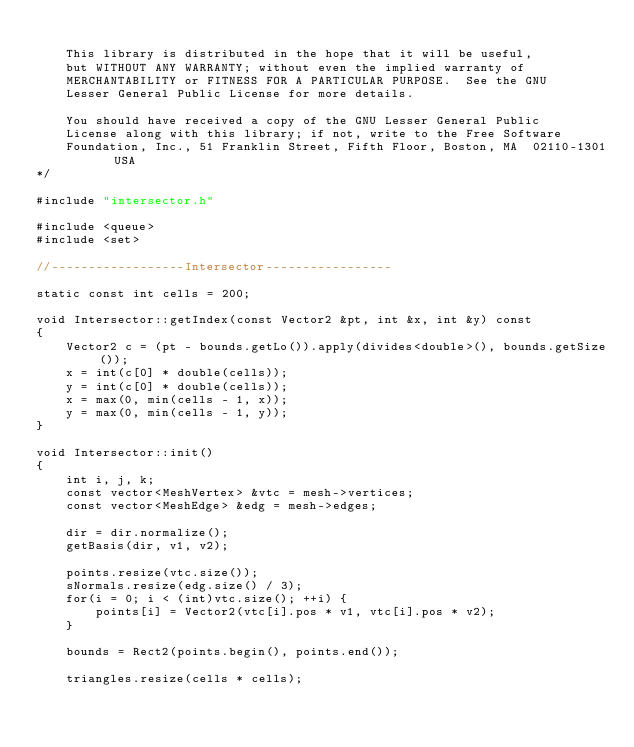Convert code to text. <code><loc_0><loc_0><loc_500><loc_500><_C++_>
    This library is distributed in the hope that it will be useful,
    but WITHOUT ANY WARRANTY; without even the implied warranty of
    MERCHANTABILITY or FITNESS FOR A PARTICULAR PURPOSE.  See the GNU
    Lesser General Public License for more details.

    You should have received a copy of the GNU Lesser General Public
    License along with this library; if not, write to the Free Software
    Foundation, Inc., 51 Franklin Street, Fifth Floor, Boston, MA  02110-1301  USA
*/

#include "intersector.h"

#include <queue>
#include <set>

//------------------Intersector-----------------

static const int cells = 200;

void Intersector::getIndex(const Vector2 &pt, int &x, int &y) const
{
    Vector2 c = (pt - bounds.getLo()).apply(divides<double>(), bounds.getSize());
    x = int(c[0] * double(cells));
    y = int(c[0] * double(cells));
    x = max(0, min(cells - 1, x));
    y = max(0, min(cells - 1, y));
}

void Intersector::init()
{
    int i, j, k;
    const vector<MeshVertex> &vtc = mesh->vertices;
    const vector<MeshEdge> &edg = mesh->edges;
    
    dir = dir.normalize();
    getBasis(dir, v1, v2);
    
    points.resize(vtc.size());
    sNormals.resize(edg.size() / 3);
    for(i = 0; i < (int)vtc.size(); ++i) {
        points[i] = Vector2(vtc[i].pos * v1, vtc[i].pos * v2);
    }
    
    bounds = Rect2(points.begin(), points.end());
    
    triangles.resize(cells * cells);</code> 